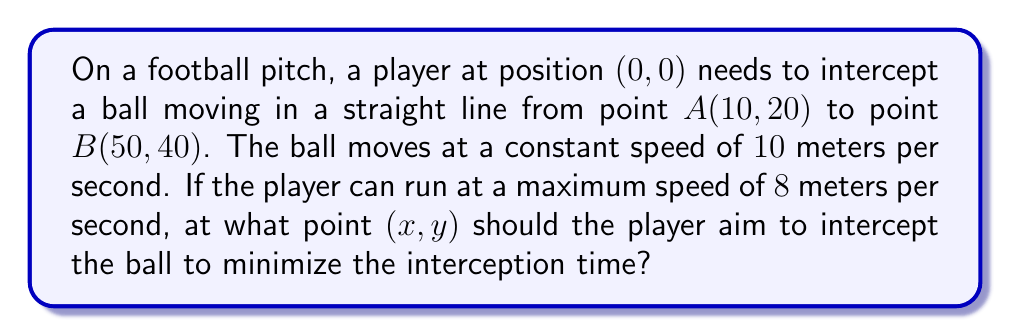Give your solution to this math problem. To solve this problem, we'll use the concept of relative motion and minimize the time of interception. Let's approach this step-by-step:

1) First, let's parameterize the ball's position as a function of time t:
   $$ x_b(t) = 10 + 40t $$
   $$ y_b(t) = 20 + 20t $$
   where t is the fraction of the total journey (0 ≤ t ≤ 1)

2) The speed of the ball is 10 m/s, so the time taken for the ball to reach any point (x, y) on its path is:
   $$ T_b = \frac{\sqrt{(x-10)^2 + (y-20)^2}}{10} $$

3) The time taken for the player to reach the same point (x, y) is:
   $$ T_p = \frac{\sqrt{x^2 + y^2}}{8} $$

4) For interception, these times must be equal:
   $$ \frac{\sqrt{(x-10)^2 + (y-20)^2}}{10} = \frac{\sqrt{x^2 + y^2}}{8} $$

5) Squaring both sides and simplifying:
   $$ 64((x-10)^2 + (y-20)^2) = 100(x^2 + y^2) $$

6) Expanding:
   $$ 64x^2 - 1280x + 64y^2 - 2560y + 25600 = 100x^2 + 100y^2 $$

7) Rearranging:
   $$ 36x^2 + 36y^2 - 1280x - 2560y + 25600 = 0 $$

8) This is the equation of a circle. The center (h, k) and radius r can be found:
   $$ h = \frac{1280}{72} = \frac{160}{9} \approx 17.78 $$
   $$ k = \frac{2560}{72} = \frac{320}{9} \approx 35.56 $$
   $$ r^2 = (\frac{160}{9})^2 + (\frac{320}{9})^2 - \frac{25600}{36} = \frac{6400}{81} $$
   $$ r = \frac{80}{9} \approx 8.89 $$

9) The interception point is where this circle intersects the line of the ball's path. Substituting the parametric equations of the ball's path into the circle equation:
   $$ (10+40t - \frac{160}{9})^2 + (20+20t - \frac{320}{9})^2 = (\frac{80}{9})^2 $$

10) Solving this quadratic equation in t gives t ≈ 0.3978

11) Substituting this back into the ball's path equations:
    $$ x = 10 + 40(0.3978) \approx 25.91 $$
    $$ y = 20 + 20(0.3978) \approx 27.96 $$

[asy]
import geometry;

size(200);
draw((0,0)--(50,40), blue);
draw(circle((160/9,320/9),80/9), red);
dot((0,0), green);
dot((10,20), blue);
dot((50,40), blue);
dot((25.91,27.96), red);
label("Player", (0,0), SW, green);
label("A", (10,20), NW, blue);
label("B", (50,40), NE, blue);
label("Interception", (25.91,27.96), SE, red);
[/asy]
Answer: The optimal interception point is approximately (25.91, 27.96) meters from the player's starting position. 